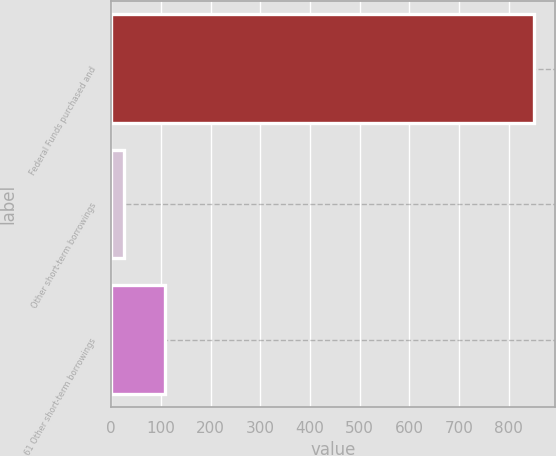Convert chart to OTSL. <chart><loc_0><loc_0><loc_500><loc_500><bar_chart><fcel>Federal Funds purchased and<fcel>Other short-term borrowings<fcel>61 Other short-term borrowings<nl><fcel>851<fcel>25<fcel>107.6<nl></chart> 